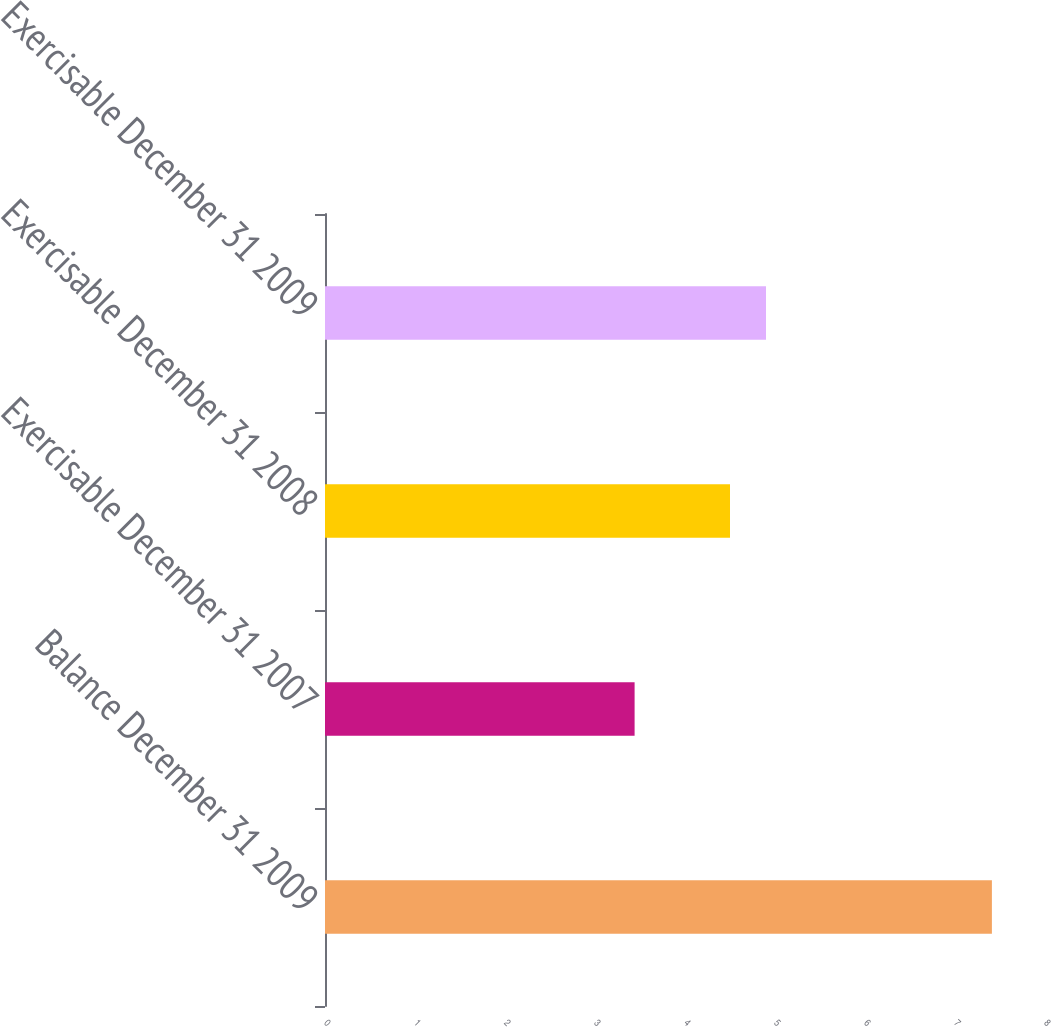Convert chart to OTSL. <chart><loc_0><loc_0><loc_500><loc_500><bar_chart><fcel>Balance December 31 2009<fcel>Exercisable December 31 2007<fcel>Exercisable December 31 2008<fcel>Exercisable December 31 2009<nl><fcel>7.41<fcel>3.44<fcel>4.5<fcel>4.9<nl></chart> 